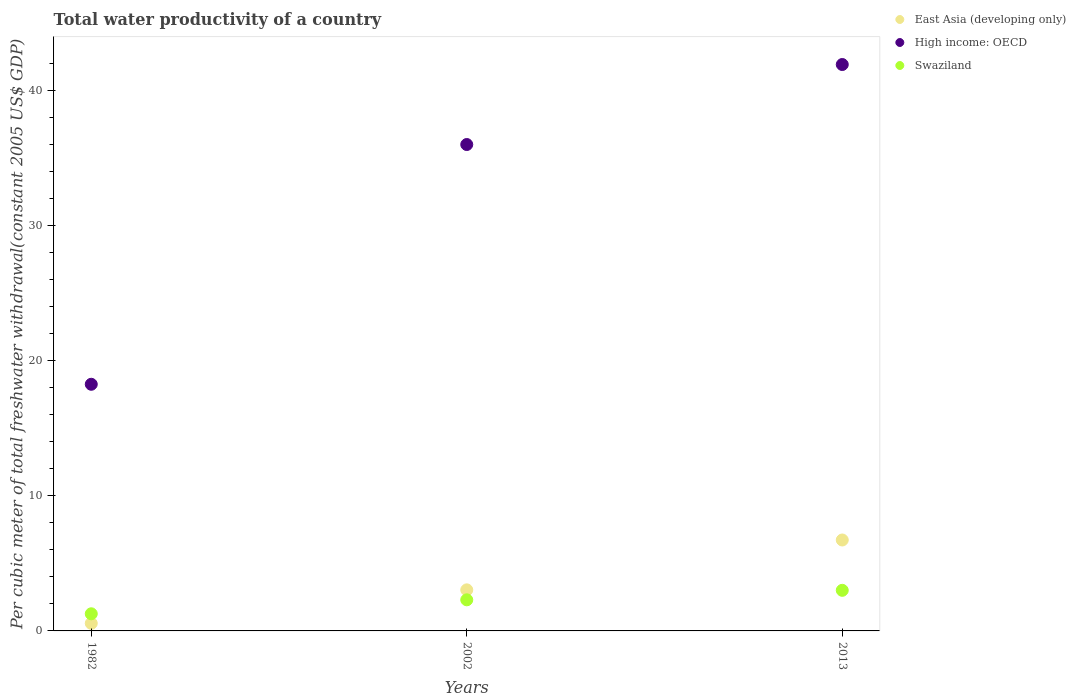Is the number of dotlines equal to the number of legend labels?
Give a very brief answer. Yes. What is the total water productivity in High income: OECD in 1982?
Make the answer very short. 18.25. Across all years, what is the maximum total water productivity in High income: OECD?
Ensure brevity in your answer.  41.9. Across all years, what is the minimum total water productivity in High income: OECD?
Provide a short and direct response. 18.25. What is the total total water productivity in East Asia (developing only) in the graph?
Your answer should be very brief. 10.32. What is the difference between the total water productivity in Swaziland in 2002 and that in 2013?
Keep it short and to the point. -0.7. What is the difference between the total water productivity in Swaziland in 2002 and the total water productivity in High income: OECD in 2013?
Your response must be concise. -39.6. What is the average total water productivity in High income: OECD per year?
Give a very brief answer. 32.04. In the year 1982, what is the difference between the total water productivity in Swaziland and total water productivity in High income: OECD?
Offer a very short reply. -16.98. In how many years, is the total water productivity in Swaziland greater than 26 US$?
Keep it short and to the point. 0. What is the ratio of the total water productivity in East Asia (developing only) in 1982 to that in 2013?
Make the answer very short. 0.08. Is the total water productivity in High income: OECD in 2002 less than that in 2013?
Keep it short and to the point. Yes. What is the difference between the highest and the second highest total water productivity in High income: OECD?
Your answer should be very brief. 5.92. What is the difference between the highest and the lowest total water productivity in Swaziland?
Your response must be concise. 1.74. Is the total water productivity in High income: OECD strictly greater than the total water productivity in Swaziland over the years?
Offer a terse response. Yes. Is the total water productivity in Swaziland strictly less than the total water productivity in High income: OECD over the years?
Your response must be concise. Yes. How many dotlines are there?
Your answer should be very brief. 3. How many years are there in the graph?
Your answer should be very brief. 3. Does the graph contain grids?
Keep it short and to the point. No. Where does the legend appear in the graph?
Keep it short and to the point. Top right. What is the title of the graph?
Provide a succinct answer. Total water productivity of a country. Does "Djibouti" appear as one of the legend labels in the graph?
Offer a very short reply. No. What is the label or title of the X-axis?
Provide a succinct answer. Years. What is the label or title of the Y-axis?
Your answer should be compact. Per cubic meter of total freshwater withdrawal(constant 2005 US$ GDP). What is the Per cubic meter of total freshwater withdrawal(constant 2005 US$ GDP) of East Asia (developing only) in 1982?
Give a very brief answer. 0.56. What is the Per cubic meter of total freshwater withdrawal(constant 2005 US$ GDP) of High income: OECD in 1982?
Your answer should be compact. 18.25. What is the Per cubic meter of total freshwater withdrawal(constant 2005 US$ GDP) of Swaziland in 1982?
Your answer should be compact. 1.27. What is the Per cubic meter of total freshwater withdrawal(constant 2005 US$ GDP) in East Asia (developing only) in 2002?
Give a very brief answer. 3.04. What is the Per cubic meter of total freshwater withdrawal(constant 2005 US$ GDP) of High income: OECD in 2002?
Ensure brevity in your answer.  35.98. What is the Per cubic meter of total freshwater withdrawal(constant 2005 US$ GDP) of Swaziland in 2002?
Provide a short and direct response. 2.3. What is the Per cubic meter of total freshwater withdrawal(constant 2005 US$ GDP) in East Asia (developing only) in 2013?
Keep it short and to the point. 6.73. What is the Per cubic meter of total freshwater withdrawal(constant 2005 US$ GDP) of High income: OECD in 2013?
Provide a short and direct response. 41.9. What is the Per cubic meter of total freshwater withdrawal(constant 2005 US$ GDP) of Swaziland in 2013?
Keep it short and to the point. 3. Across all years, what is the maximum Per cubic meter of total freshwater withdrawal(constant 2005 US$ GDP) of East Asia (developing only)?
Ensure brevity in your answer.  6.73. Across all years, what is the maximum Per cubic meter of total freshwater withdrawal(constant 2005 US$ GDP) in High income: OECD?
Ensure brevity in your answer.  41.9. Across all years, what is the maximum Per cubic meter of total freshwater withdrawal(constant 2005 US$ GDP) in Swaziland?
Make the answer very short. 3. Across all years, what is the minimum Per cubic meter of total freshwater withdrawal(constant 2005 US$ GDP) of East Asia (developing only)?
Ensure brevity in your answer.  0.56. Across all years, what is the minimum Per cubic meter of total freshwater withdrawal(constant 2005 US$ GDP) in High income: OECD?
Your response must be concise. 18.25. Across all years, what is the minimum Per cubic meter of total freshwater withdrawal(constant 2005 US$ GDP) in Swaziland?
Provide a succinct answer. 1.27. What is the total Per cubic meter of total freshwater withdrawal(constant 2005 US$ GDP) of East Asia (developing only) in the graph?
Make the answer very short. 10.32. What is the total Per cubic meter of total freshwater withdrawal(constant 2005 US$ GDP) of High income: OECD in the graph?
Provide a succinct answer. 96.13. What is the total Per cubic meter of total freshwater withdrawal(constant 2005 US$ GDP) in Swaziland in the graph?
Offer a very short reply. 6.57. What is the difference between the Per cubic meter of total freshwater withdrawal(constant 2005 US$ GDP) in East Asia (developing only) in 1982 and that in 2002?
Keep it short and to the point. -2.48. What is the difference between the Per cubic meter of total freshwater withdrawal(constant 2005 US$ GDP) in High income: OECD in 1982 and that in 2002?
Offer a terse response. -17.74. What is the difference between the Per cubic meter of total freshwater withdrawal(constant 2005 US$ GDP) of Swaziland in 1982 and that in 2002?
Ensure brevity in your answer.  -1.03. What is the difference between the Per cubic meter of total freshwater withdrawal(constant 2005 US$ GDP) of East Asia (developing only) in 1982 and that in 2013?
Your answer should be compact. -6.17. What is the difference between the Per cubic meter of total freshwater withdrawal(constant 2005 US$ GDP) in High income: OECD in 1982 and that in 2013?
Provide a short and direct response. -23.66. What is the difference between the Per cubic meter of total freshwater withdrawal(constant 2005 US$ GDP) in Swaziland in 1982 and that in 2013?
Your answer should be compact. -1.74. What is the difference between the Per cubic meter of total freshwater withdrawal(constant 2005 US$ GDP) of East Asia (developing only) in 2002 and that in 2013?
Give a very brief answer. -3.69. What is the difference between the Per cubic meter of total freshwater withdrawal(constant 2005 US$ GDP) of High income: OECD in 2002 and that in 2013?
Keep it short and to the point. -5.92. What is the difference between the Per cubic meter of total freshwater withdrawal(constant 2005 US$ GDP) of Swaziland in 2002 and that in 2013?
Provide a succinct answer. -0.7. What is the difference between the Per cubic meter of total freshwater withdrawal(constant 2005 US$ GDP) of East Asia (developing only) in 1982 and the Per cubic meter of total freshwater withdrawal(constant 2005 US$ GDP) of High income: OECD in 2002?
Keep it short and to the point. -35.42. What is the difference between the Per cubic meter of total freshwater withdrawal(constant 2005 US$ GDP) in East Asia (developing only) in 1982 and the Per cubic meter of total freshwater withdrawal(constant 2005 US$ GDP) in Swaziland in 2002?
Provide a succinct answer. -1.74. What is the difference between the Per cubic meter of total freshwater withdrawal(constant 2005 US$ GDP) in High income: OECD in 1982 and the Per cubic meter of total freshwater withdrawal(constant 2005 US$ GDP) in Swaziland in 2002?
Provide a succinct answer. 15.95. What is the difference between the Per cubic meter of total freshwater withdrawal(constant 2005 US$ GDP) of East Asia (developing only) in 1982 and the Per cubic meter of total freshwater withdrawal(constant 2005 US$ GDP) of High income: OECD in 2013?
Give a very brief answer. -41.34. What is the difference between the Per cubic meter of total freshwater withdrawal(constant 2005 US$ GDP) of East Asia (developing only) in 1982 and the Per cubic meter of total freshwater withdrawal(constant 2005 US$ GDP) of Swaziland in 2013?
Your answer should be very brief. -2.44. What is the difference between the Per cubic meter of total freshwater withdrawal(constant 2005 US$ GDP) of High income: OECD in 1982 and the Per cubic meter of total freshwater withdrawal(constant 2005 US$ GDP) of Swaziland in 2013?
Your answer should be very brief. 15.24. What is the difference between the Per cubic meter of total freshwater withdrawal(constant 2005 US$ GDP) of East Asia (developing only) in 2002 and the Per cubic meter of total freshwater withdrawal(constant 2005 US$ GDP) of High income: OECD in 2013?
Your answer should be compact. -38.86. What is the difference between the Per cubic meter of total freshwater withdrawal(constant 2005 US$ GDP) of East Asia (developing only) in 2002 and the Per cubic meter of total freshwater withdrawal(constant 2005 US$ GDP) of Swaziland in 2013?
Keep it short and to the point. 0.03. What is the difference between the Per cubic meter of total freshwater withdrawal(constant 2005 US$ GDP) of High income: OECD in 2002 and the Per cubic meter of total freshwater withdrawal(constant 2005 US$ GDP) of Swaziland in 2013?
Your answer should be compact. 32.98. What is the average Per cubic meter of total freshwater withdrawal(constant 2005 US$ GDP) in East Asia (developing only) per year?
Make the answer very short. 3.44. What is the average Per cubic meter of total freshwater withdrawal(constant 2005 US$ GDP) in High income: OECD per year?
Your answer should be compact. 32.04. What is the average Per cubic meter of total freshwater withdrawal(constant 2005 US$ GDP) in Swaziland per year?
Offer a terse response. 2.19. In the year 1982, what is the difference between the Per cubic meter of total freshwater withdrawal(constant 2005 US$ GDP) in East Asia (developing only) and Per cubic meter of total freshwater withdrawal(constant 2005 US$ GDP) in High income: OECD?
Make the answer very short. -17.69. In the year 1982, what is the difference between the Per cubic meter of total freshwater withdrawal(constant 2005 US$ GDP) of East Asia (developing only) and Per cubic meter of total freshwater withdrawal(constant 2005 US$ GDP) of Swaziland?
Provide a short and direct response. -0.71. In the year 1982, what is the difference between the Per cubic meter of total freshwater withdrawal(constant 2005 US$ GDP) of High income: OECD and Per cubic meter of total freshwater withdrawal(constant 2005 US$ GDP) of Swaziland?
Provide a succinct answer. 16.98. In the year 2002, what is the difference between the Per cubic meter of total freshwater withdrawal(constant 2005 US$ GDP) of East Asia (developing only) and Per cubic meter of total freshwater withdrawal(constant 2005 US$ GDP) of High income: OECD?
Offer a terse response. -32.95. In the year 2002, what is the difference between the Per cubic meter of total freshwater withdrawal(constant 2005 US$ GDP) in East Asia (developing only) and Per cubic meter of total freshwater withdrawal(constant 2005 US$ GDP) in Swaziland?
Provide a succinct answer. 0.74. In the year 2002, what is the difference between the Per cubic meter of total freshwater withdrawal(constant 2005 US$ GDP) of High income: OECD and Per cubic meter of total freshwater withdrawal(constant 2005 US$ GDP) of Swaziland?
Your answer should be very brief. 33.68. In the year 2013, what is the difference between the Per cubic meter of total freshwater withdrawal(constant 2005 US$ GDP) in East Asia (developing only) and Per cubic meter of total freshwater withdrawal(constant 2005 US$ GDP) in High income: OECD?
Make the answer very short. -35.18. In the year 2013, what is the difference between the Per cubic meter of total freshwater withdrawal(constant 2005 US$ GDP) in East Asia (developing only) and Per cubic meter of total freshwater withdrawal(constant 2005 US$ GDP) in Swaziland?
Give a very brief answer. 3.72. In the year 2013, what is the difference between the Per cubic meter of total freshwater withdrawal(constant 2005 US$ GDP) of High income: OECD and Per cubic meter of total freshwater withdrawal(constant 2005 US$ GDP) of Swaziland?
Offer a terse response. 38.9. What is the ratio of the Per cubic meter of total freshwater withdrawal(constant 2005 US$ GDP) of East Asia (developing only) in 1982 to that in 2002?
Ensure brevity in your answer.  0.18. What is the ratio of the Per cubic meter of total freshwater withdrawal(constant 2005 US$ GDP) of High income: OECD in 1982 to that in 2002?
Make the answer very short. 0.51. What is the ratio of the Per cubic meter of total freshwater withdrawal(constant 2005 US$ GDP) of Swaziland in 1982 to that in 2002?
Provide a succinct answer. 0.55. What is the ratio of the Per cubic meter of total freshwater withdrawal(constant 2005 US$ GDP) of East Asia (developing only) in 1982 to that in 2013?
Give a very brief answer. 0.08. What is the ratio of the Per cubic meter of total freshwater withdrawal(constant 2005 US$ GDP) in High income: OECD in 1982 to that in 2013?
Your response must be concise. 0.44. What is the ratio of the Per cubic meter of total freshwater withdrawal(constant 2005 US$ GDP) in Swaziland in 1982 to that in 2013?
Make the answer very short. 0.42. What is the ratio of the Per cubic meter of total freshwater withdrawal(constant 2005 US$ GDP) of East Asia (developing only) in 2002 to that in 2013?
Provide a short and direct response. 0.45. What is the ratio of the Per cubic meter of total freshwater withdrawal(constant 2005 US$ GDP) in High income: OECD in 2002 to that in 2013?
Your answer should be compact. 0.86. What is the ratio of the Per cubic meter of total freshwater withdrawal(constant 2005 US$ GDP) of Swaziland in 2002 to that in 2013?
Provide a succinct answer. 0.77. What is the difference between the highest and the second highest Per cubic meter of total freshwater withdrawal(constant 2005 US$ GDP) in East Asia (developing only)?
Make the answer very short. 3.69. What is the difference between the highest and the second highest Per cubic meter of total freshwater withdrawal(constant 2005 US$ GDP) in High income: OECD?
Offer a very short reply. 5.92. What is the difference between the highest and the second highest Per cubic meter of total freshwater withdrawal(constant 2005 US$ GDP) of Swaziland?
Your answer should be very brief. 0.7. What is the difference between the highest and the lowest Per cubic meter of total freshwater withdrawal(constant 2005 US$ GDP) of East Asia (developing only)?
Provide a short and direct response. 6.17. What is the difference between the highest and the lowest Per cubic meter of total freshwater withdrawal(constant 2005 US$ GDP) of High income: OECD?
Your response must be concise. 23.66. What is the difference between the highest and the lowest Per cubic meter of total freshwater withdrawal(constant 2005 US$ GDP) in Swaziland?
Your answer should be very brief. 1.74. 